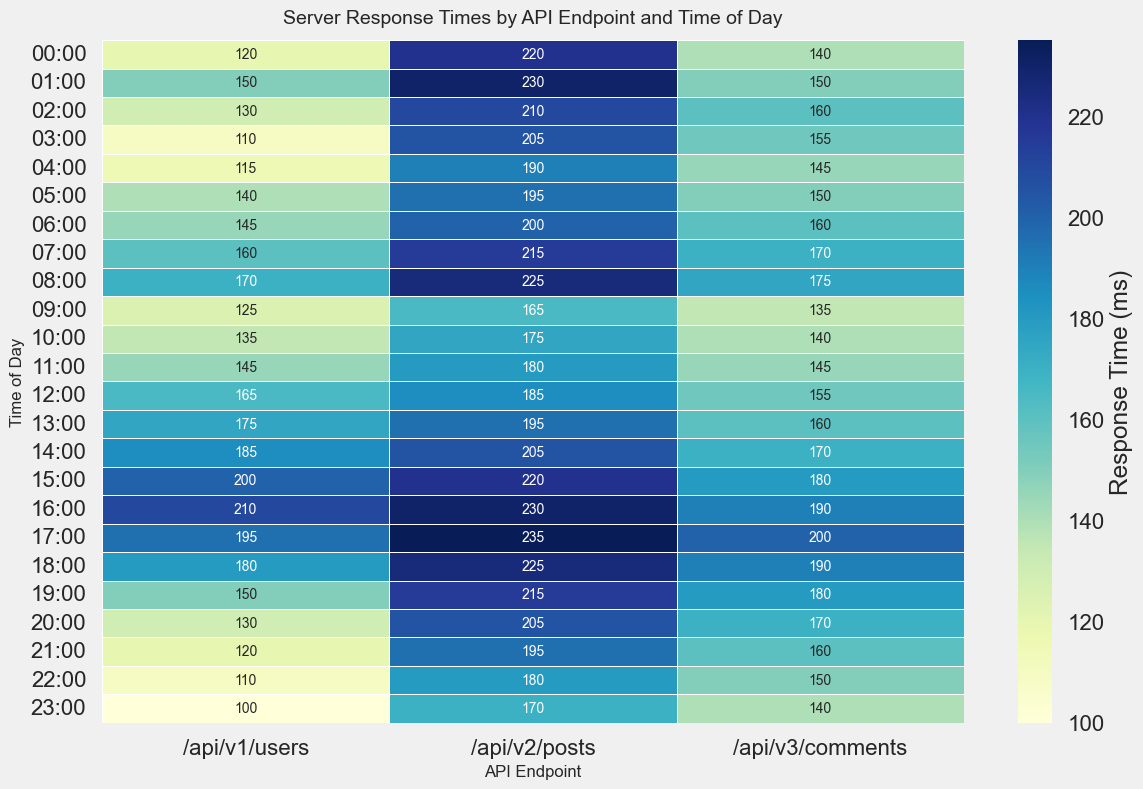Which API endpoint has the highest average response time across all times of the day? To determine the highest average response time, calculate the average response time for each API endpoint and compare them. For `/api/v1/users`, average is (120+150+...+100)/24, for `/api/v2/posts`, average is (220+230+...+170)/24, for `/api/v3/comments`, average is (140+150+...+140)/24. The highest average is `/api/v2/posts`.
Answer: /api/v2/posts What is the response time for `/api/v1/users` at 15:00 and is it higher or lower than the average response time for `/api/v3/comments` at 15:00? Look at the value for `/api/v1/users` at 15:00 which is 200 ms. Then check the value for `/api/v3/comments` at 15:00 which is 180 ms. Since 200 is greater than 180, the response time for `/api/v1/users` at 15:00 is higher.
Answer: Higher During which hour of the day does `/api/v3/comments` have its highest response time? Inspect the heatmap for the `/api/v3/comments` row and identify the highest value, which occurs at 17:00 with a value of 200 ms.
Answer: 17:00 Which time period has the lowest response time for `/api/v2/posts`? Look at the row for `/api/v2/posts` and identify the smallest value, which is at 10:00 with a value of 175 ms.
Answer: 10:00 Are the response times for `/api/v1/users` consistently increasing throughout the day? Check the response times for `/api/v1/users` from 00:00 to 23:00 and observe the pattern. The values fluctuate throughout the day and are not consistently increasing.
Answer: No How does the response time at 12:00 compare across the three endpoints? Look at the response times at 12:00 for `/api/v1/users` (165 ms), `/api/v2/posts` (185 ms), and `/api/v3/comments` (155 ms). The `/api/v3/comments` is the lowest, followed by `/api/v1/users`, and `/api/v2/posts` is the highest.
Answer: /api/v2/posts > /api/v1/users > /api/v3/comments At what times does `/api/v1/users` have the response time below 120 ms? Review the response times for `/api/v1/users` and identify times where the response time is below 120 ms: 00:00 (120 ms), 03:00 (110 ms), 04:00 (115 ms), 21:00 (120 ms), 22:00 (110 ms), and 23:00 (100 ms). Only 03:00, 04:00, 22:00, and 23:00 are below 120 ms.
Answer: 03:00, 04:00, 22:00, 23:00 Which API endpoint has the most significant spike in response time within a single hour? Compare the changes in response times for each endpoint across different hours. For `/api/v2/posts`, notice the highest spike from 09:00 (165 ms) to 10:00 (175 ms), and `/api/v1/users` doesn't exhibit a larger spike than 10 ms. `/api/v3/comments` also has no large spike. So, it is `/api/v1/users`.
Answer: /api/v2/posts Is there a specific time when all endpoints have their response times above 180 ms? Review the heatmap and see if there exists a time when the response times for all endpoints exceed 180 ms. At 14:00, `/api/v1/users` (185 ms), `/api/v2/posts` (205 ms), and `/api/v3/comments` (170 ms) indicate no time when all exceed 180 ms.
Answer: No Does the response time for `/api/v3/comments` at 19:00 align with the average response time for `/api/v1/users` at 19:00? Find the response time for `/api/v3/comments` at 19:00 (180 ms) and the average response time for `/api/v1/users` which is around (∑ response times/24). `/api/v1/users` 150 ms and `/api/v3/comments` 180 ms are few points off
Answer: No 